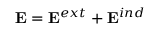Convert formula to latex. <formula><loc_0><loc_0><loc_500><loc_500>{ E } = { E } ^ { e x t } + { E } ^ { i n d }</formula> 